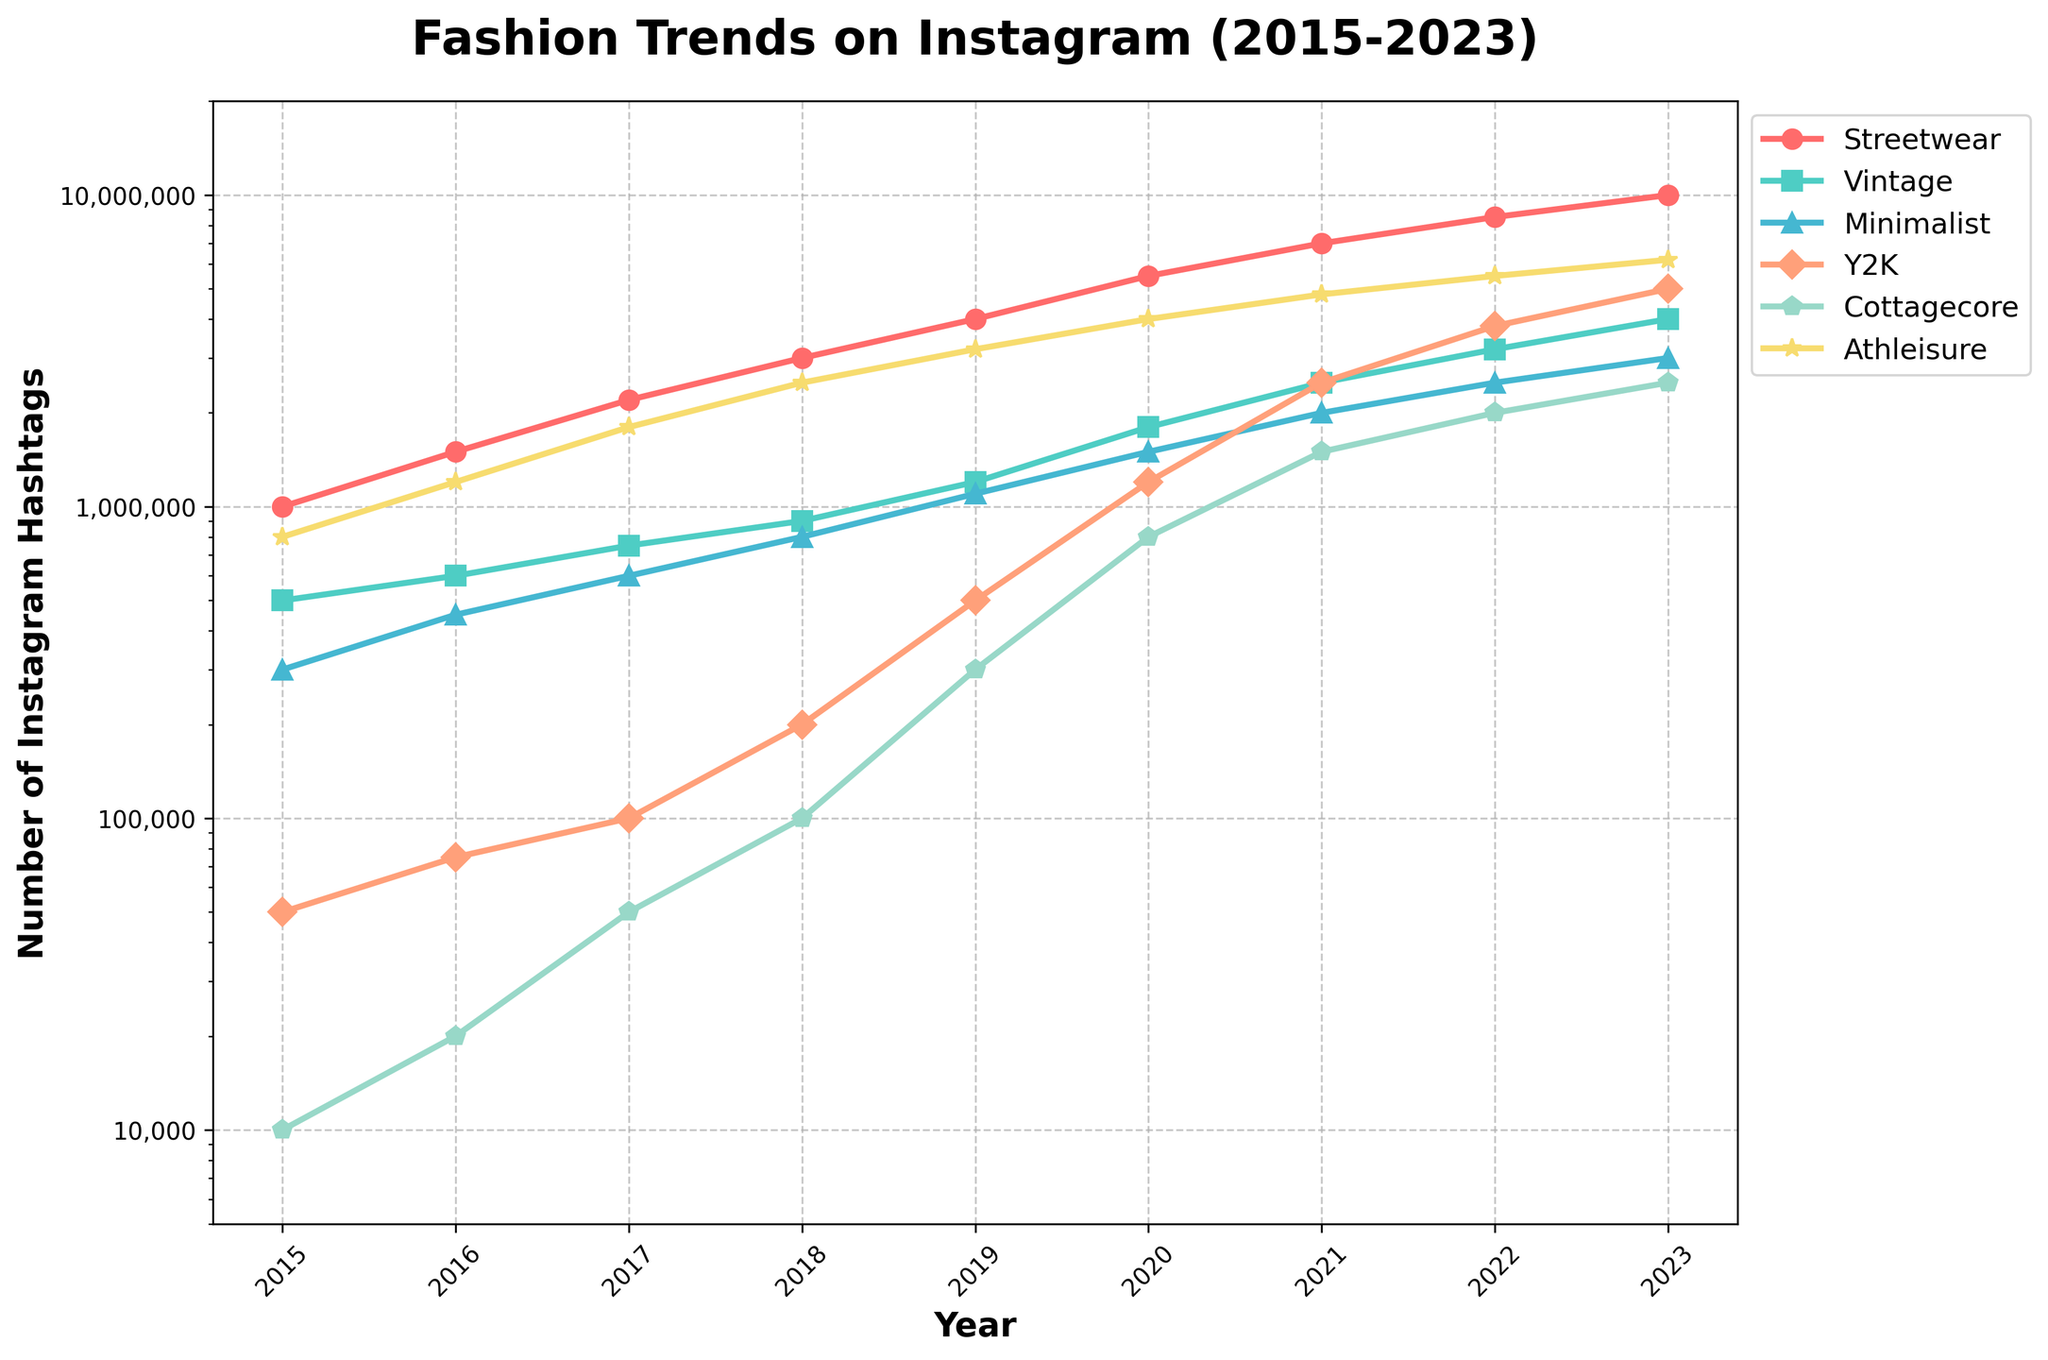what is the trend in popularity of the Y2K fashion style from 2015 to 2023? From the chart, we can see the Y2K line (orange color with diamond markers) rising steadily over the years. The number of hashtags starts at 50,000 in 2015 and increases to 5,000,000 in 2023. This indicates a significant upward trend in the popularity of the Y2K style.
Answer: Steadily increasing which fashion style had the highest number of hashtags in 2023? By looking at the endpoints of the lines in the year 2023, the Streetwear line is the highest, peaking at 10,000,000 hashtags.
Answer: Streetwear compare the hashtag growth of Streetwear and Cottagecore between 2015 and 2018? Streetwear starts at 1,000,000 in 2015 and increases to 3,000,000 by 2018, growing by 2,000,000. Cottagecore starts at 10,000 in 2015 and increases to 100,000 by 2018, growing by 90,000. The growth of Streetwear is significantly higher.
Answer: Streetwear grew by 2,000,000; Cottagecore by 90,000 what is the average number of hashtags for Vintage fashion style in the years 2021, 2022, and 2023? The number of Vintage hashtags in 2021, 2022, and 2023 can be found on the chart: 2,500,000, 3,200,000, and 4,000,000 respectively. Average = (2,500,000 + 3,200,000 + 4,000,000) / 3 = 3,233,333.33
Answer: 3,233,333.33 which fashion style has shown the most consistent growth over the period 2015 to 2023? By examining the lines, Streetwear's growth appears the most consistent, increasing steadily each year without any dips or plateaus.
Answer: Streetwear how does the popularity of Minimalist fashion in 2016 compare to Cottagecore in 2020? From the chart, Minimalist had 450,000 hashtags in 2016, while Cottagecore had 800,000 hashtags in 2020. Cottagecore was more popular in 2020 compared to Minimalist in 2016.
Answer: Cottagecore in 2020 had more hashtags identify the fashion styles that had more than 2,000,000 hashtags in 2023 The lines for Streetwear, Vintage, Minimalist, Y2K, Cottagecore, and Athleisure all exceed 2,000,000 hashtags in 2023, based on their endpoints.
Answer: Streetwear, Vintage, Minimalist, Y2K, Cottagecore, Athleisure which year did Athleisure reach 4,000,000 hashtags? Observing Athleisure's (yellow color with start markers) line, it reached 4,000,000 hashtags in 2020.
Answer: 2020 